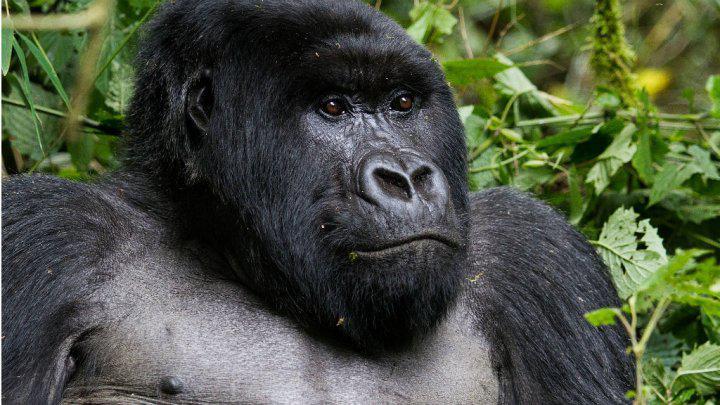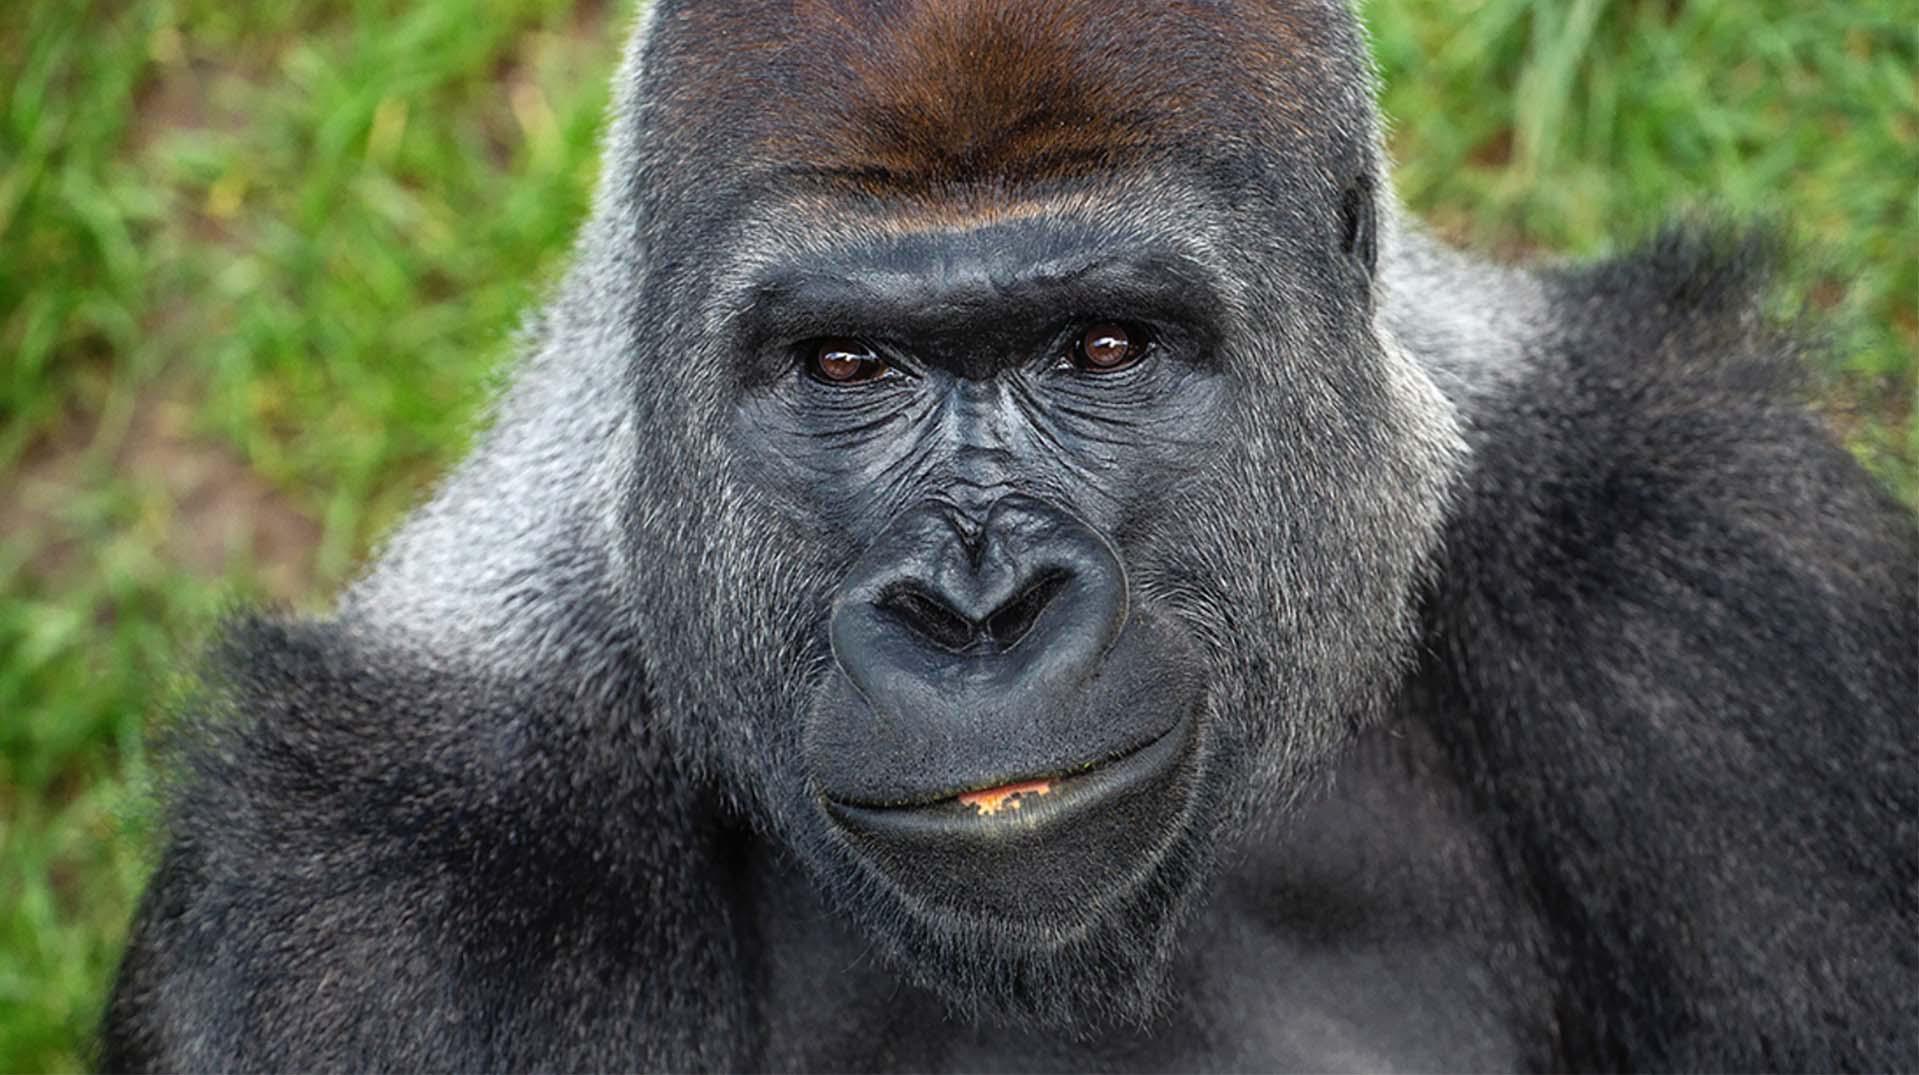The first image is the image on the left, the second image is the image on the right. For the images displayed, is the sentence "There is a large gorilla in one image and at least a baby gorilla in the other image." factually correct? Answer yes or no. No. The first image is the image on the left, the second image is the image on the right. Evaluate the accuracy of this statement regarding the images: "The right image includes a fluffy baby gorilla with its tongue visible.". Is it true? Answer yes or no. No. 